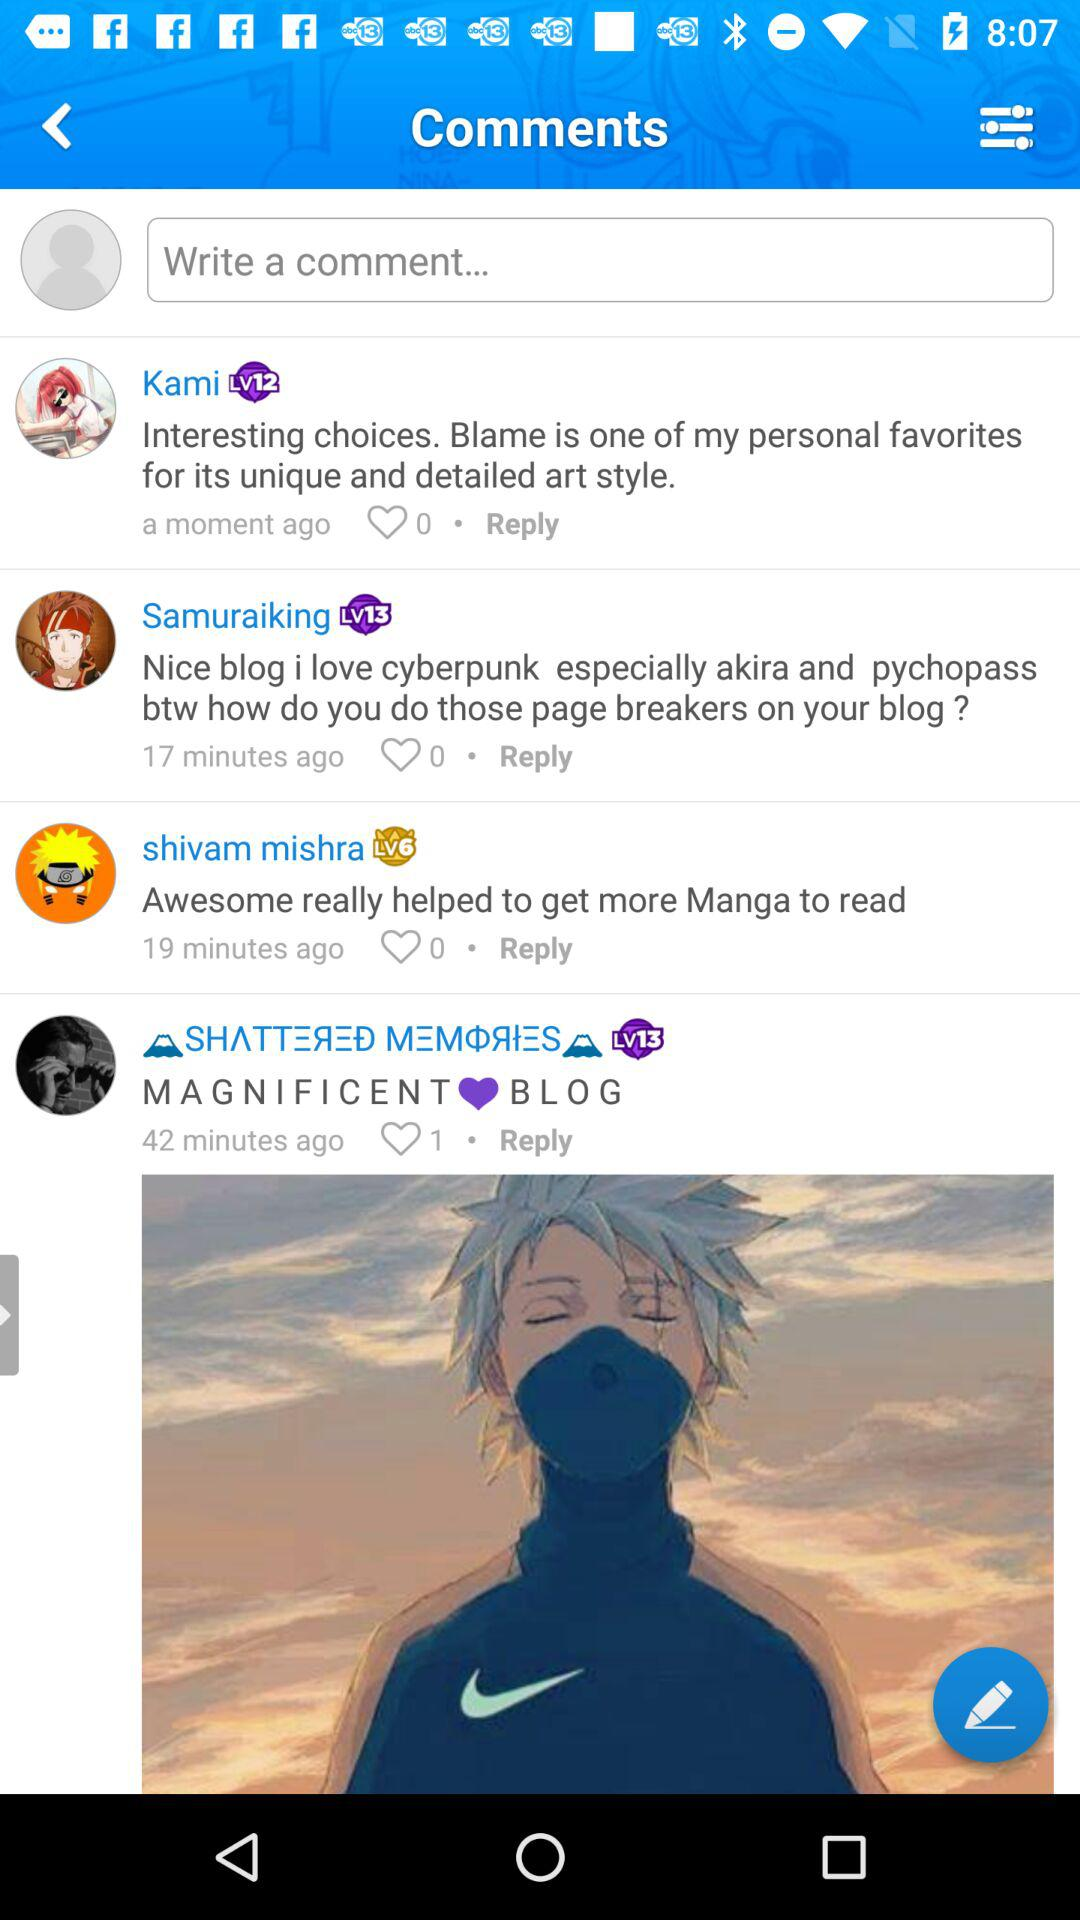How many comments are there in total?
Answer the question using a single word or phrase. 4 